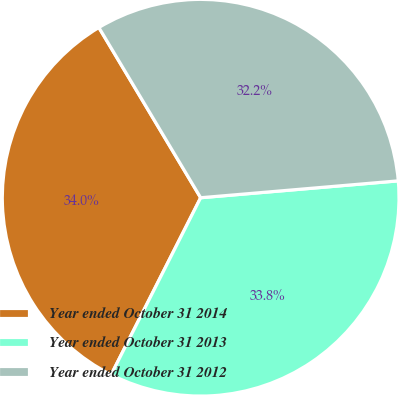<chart> <loc_0><loc_0><loc_500><loc_500><pie_chart><fcel>Year ended October 31 2014<fcel>Year ended October 31 2013<fcel>Year ended October 31 2012<nl><fcel>33.97%<fcel>33.81%<fcel>32.22%<nl></chart> 